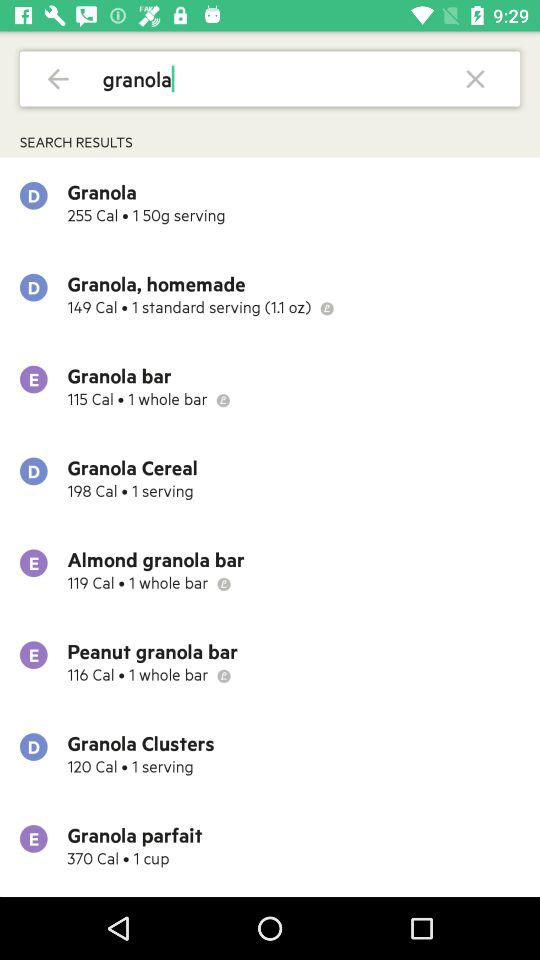How many calories are there in "Granola"? There are 255 calories in "Granola". 